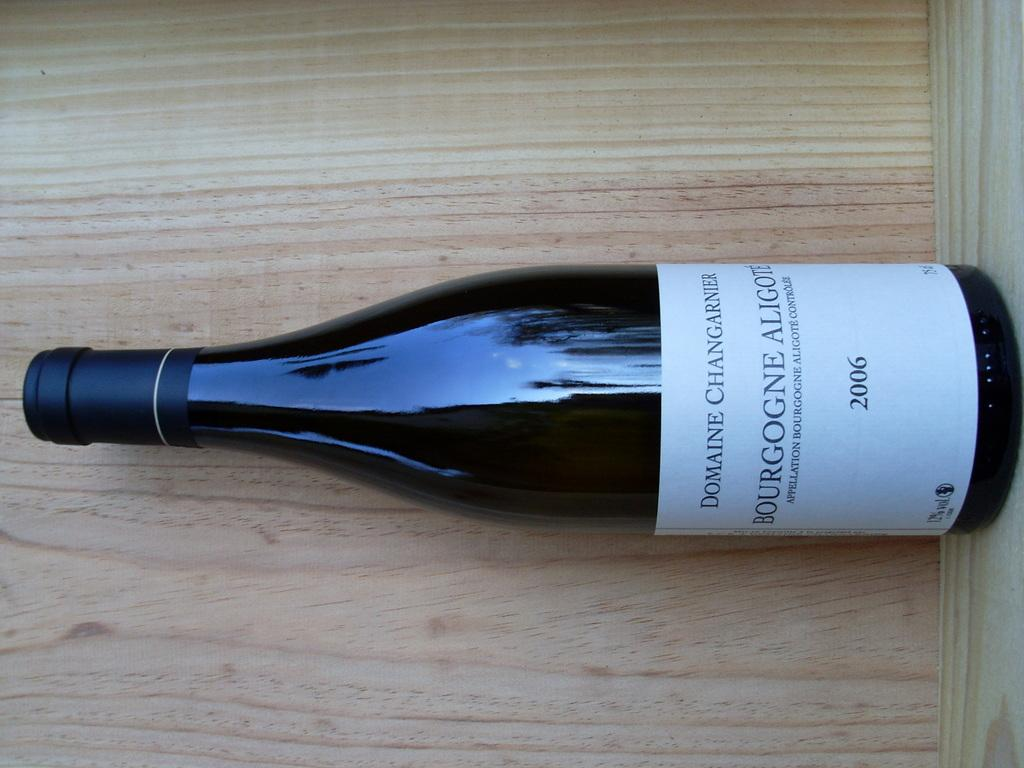<image>
Describe the image concisely. A bottle of wine from the year 2006 sits in a wooden crate. 